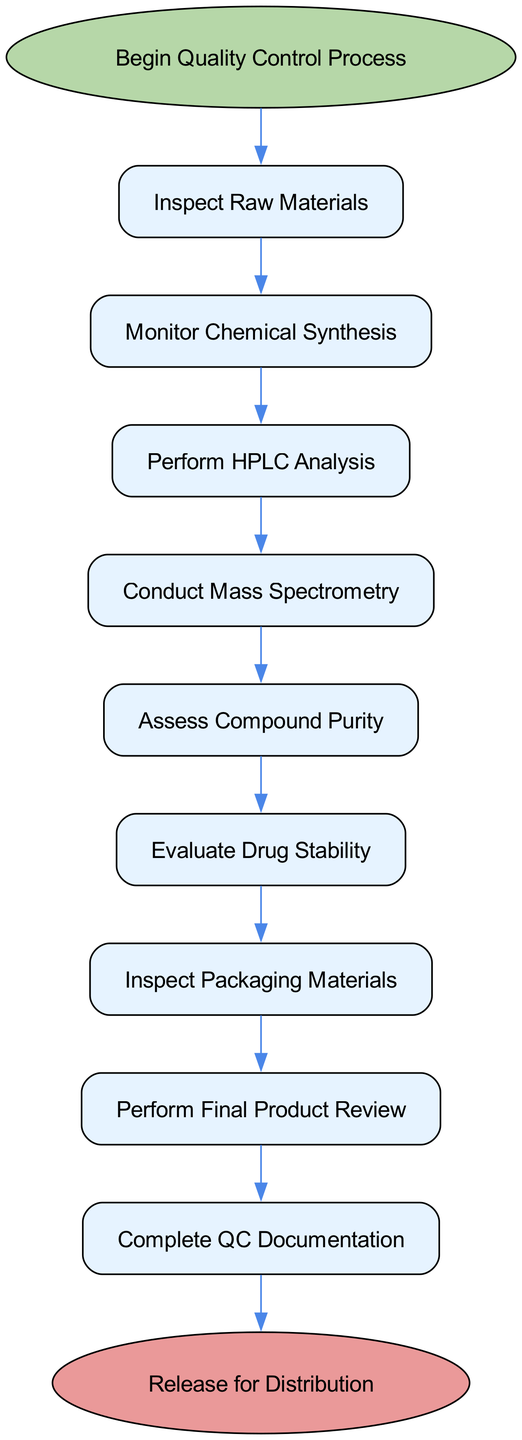What is the first step in the quality control process? The diagram indicates that the process begins with the node labeled "Begin Quality Control Process." This is the starting point in the flowchart.
Answer: Begin Quality Control Process How many steps are there in total from start to end? By counting the nodes from the starting point to the endpoint, there are eleven nodes in total, including both the start and end nodes.
Answer: Eleven Which analysis is conducted after performing HPLC analysis? The diagram shows that the step following "Perform HPLC Analysis" is "Conduct Mass Spectrometry." This directly outlines the sequence of operations in the flowchart.
Answer: Conduct Mass Spectrometry What is the final check before completing the quality control documentation? According to the flowchart, the final check before documentation is "Perform Final Product Review," which is the step just prior to the documentation stage.
Answer: Perform Final Product Review What are the two assessments performed after monitoring chemical synthesis? The flowchart indicates that after "Monitor Chemical Synthesis," the two assessments that follow are "Perform HPLC Analysis" and "Conduct Mass Spectrometry." This shows the sequential operations that need to be performed.
Answer: Perform HPLC Analysis, Conduct Mass Spectrometry 